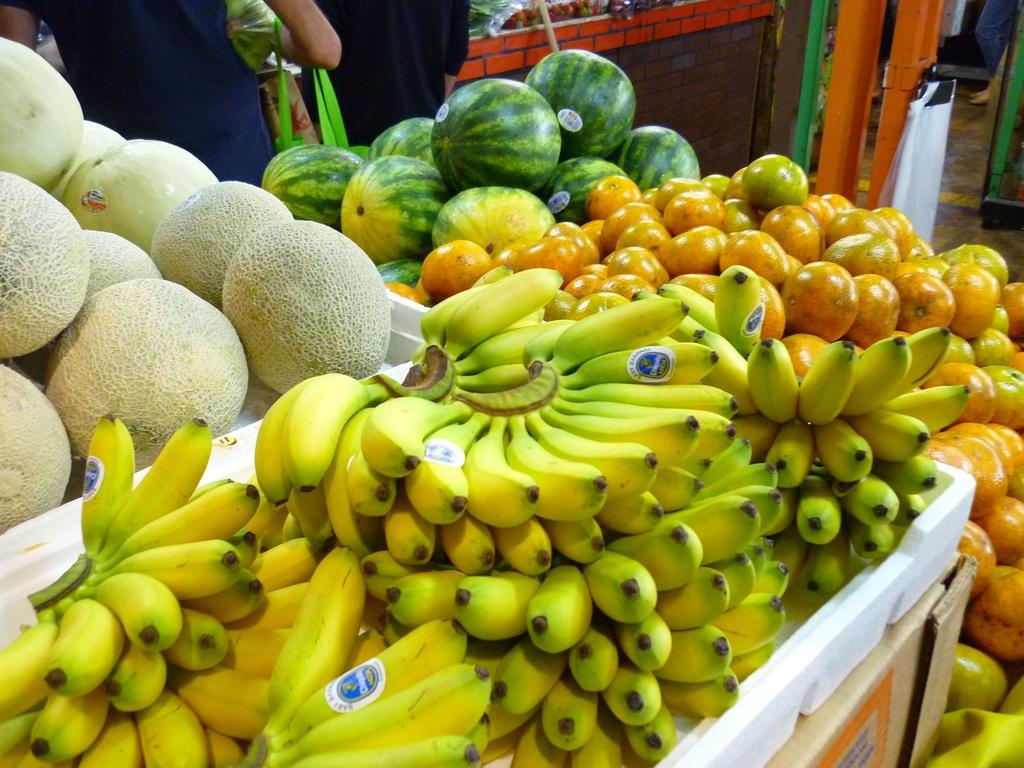How would you summarize this image in a sentence or two? Here we can see bananas,watermelons,melons and some other fruits on a platform. On the right at the bottom corner we can see a carton box. In the background there are two persons and a person is carrying a bag on the hand and we can also see a stick and some other items and on the right at the top corner we can see a person legs. 